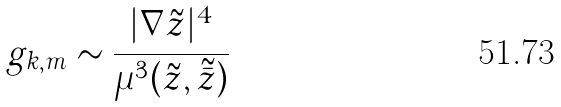<formula> <loc_0><loc_0><loc_500><loc_500>g _ { k , m } \sim \frac { | \nabla \tilde { z } | ^ { 4 } } { \mu ^ { 3 } ( \tilde { z } , \tilde { \bar { z } } ) }</formula> 